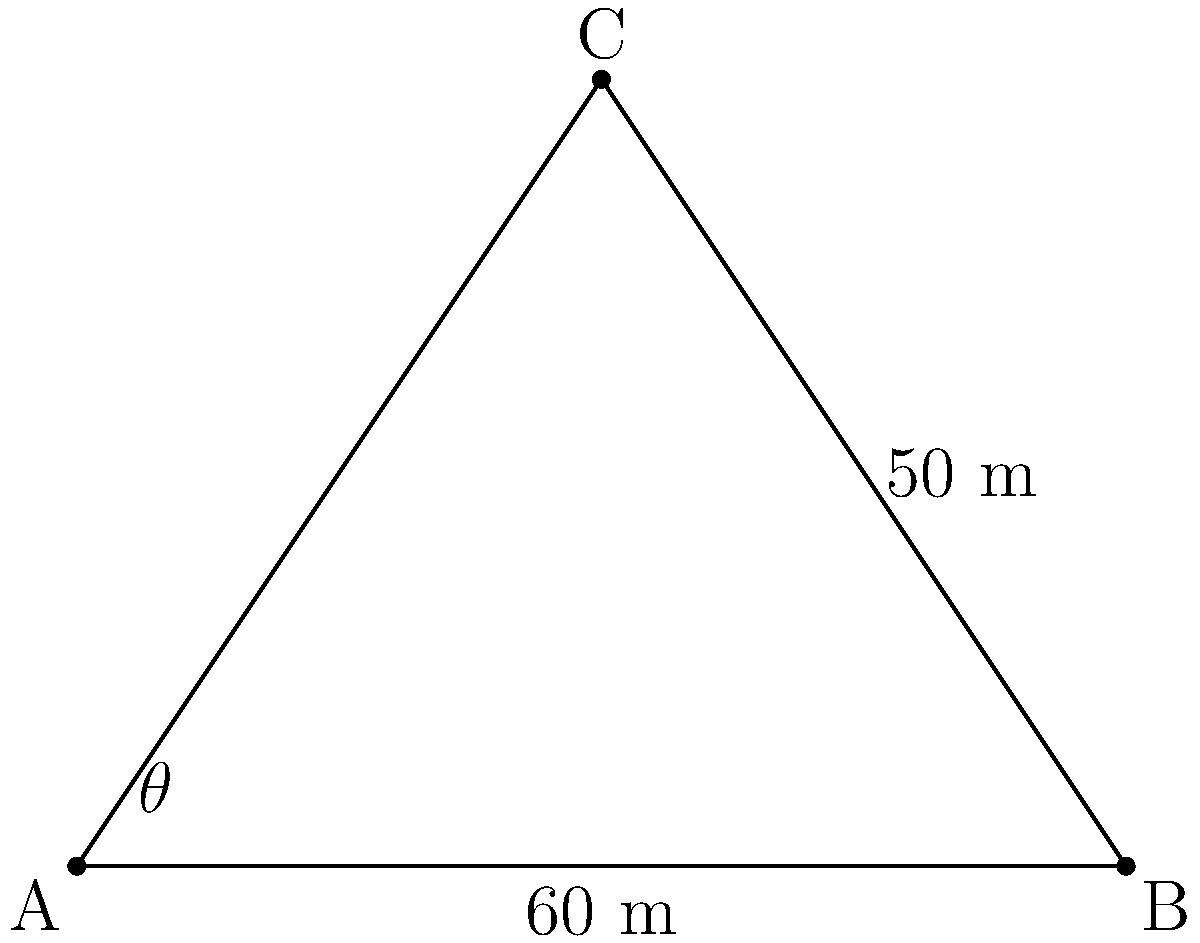An ancient watchtower is located at point C on a cliff overlooking two landmark points A and B on the ground below. The distance between A and B is 60 meters, and the distance from B to C is 50 meters. If the angle $\angle ACB$ is 90°, what is the viewing angle $\theta$ (in degrees) from the watchtower to points A and B? To find the viewing angle $\theta$, we can follow these steps:

1) First, we need to find the length of AC using the Pythagorean theorem in triangle ABC:

   $AC^2 + 60^2 = 50^2$
   $AC^2 = 50^2 - 60^2 = 2500 - 3600 = -1100$
   $AC = \sqrt{1100} \approx 33.17$ meters

2) Now we have a triangle ABC where we know all three sides:
   AB = 60 m, BC = 50 m, AC ≈ 33.17 m

3) We can use the cosine law to find $\theta$:

   $\cos(\theta) = \frac{AC^2 + BC^2 - AB^2}{2(AC)(BC)}$

4) Substituting the values:

   $\cos(\theta) = \frac{33.17^2 + 50^2 - 60^2}{2(33.17)(50)}$

5) Simplifying:

   $\cos(\theta) = \frac{1100.2489 + 2500 - 3600}{3317}$
   $\cos(\theta) = \frac{0.2489}{3317} \approx 0.000075$

6) To get $\theta$, we take the inverse cosine (arccos) of both sides:

   $\theta = \arccos(0.000075) \approx 89.996°$

7) Rounding to the nearest degree:

   $\theta \approx 90°$
Answer: 90° 